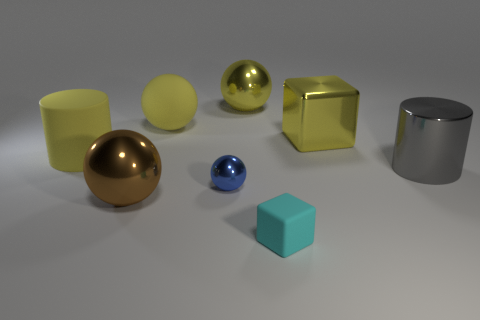Is the number of small yellow things less than the number of big metal blocks?
Ensure brevity in your answer.  Yes. What is the shape of the yellow shiny thing to the right of the thing that is in front of the big metallic sphere in front of the yellow metal ball?
Make the answer very short. Cube. The metal thing that is the same color as the shiny block is what shape?
Offer a terse response. Sphere. Are there any small blue matte things?
Offer a very short reply. No. Do the gray shiny cylinder and the yellow thing that is on the right side of the tiny block have the same size?
Your answer should be compact. Yes. Are there any tiny things that are right of the yellow metallic thing that is left of the tiny rubber thing?
Make the answer very short. Yes. What material is the object that is both in front of the big yellow cylinder and behind the blue shiny ball?
Your answer should be compact. Metal. What is the color of the large shiny sphere behind the large cylinder that is in front of the large cylinder that is to the left of the brown metallic ball?
Make the answer very short. Yellow. The metal ball that is the same size as the matte block is what color?
Provide a succinct answer. Blue. There is a big metal block; is it the same color as the big sphere that is on the left side of the big yellow rubber ball?
Offer a very short reply. No. 